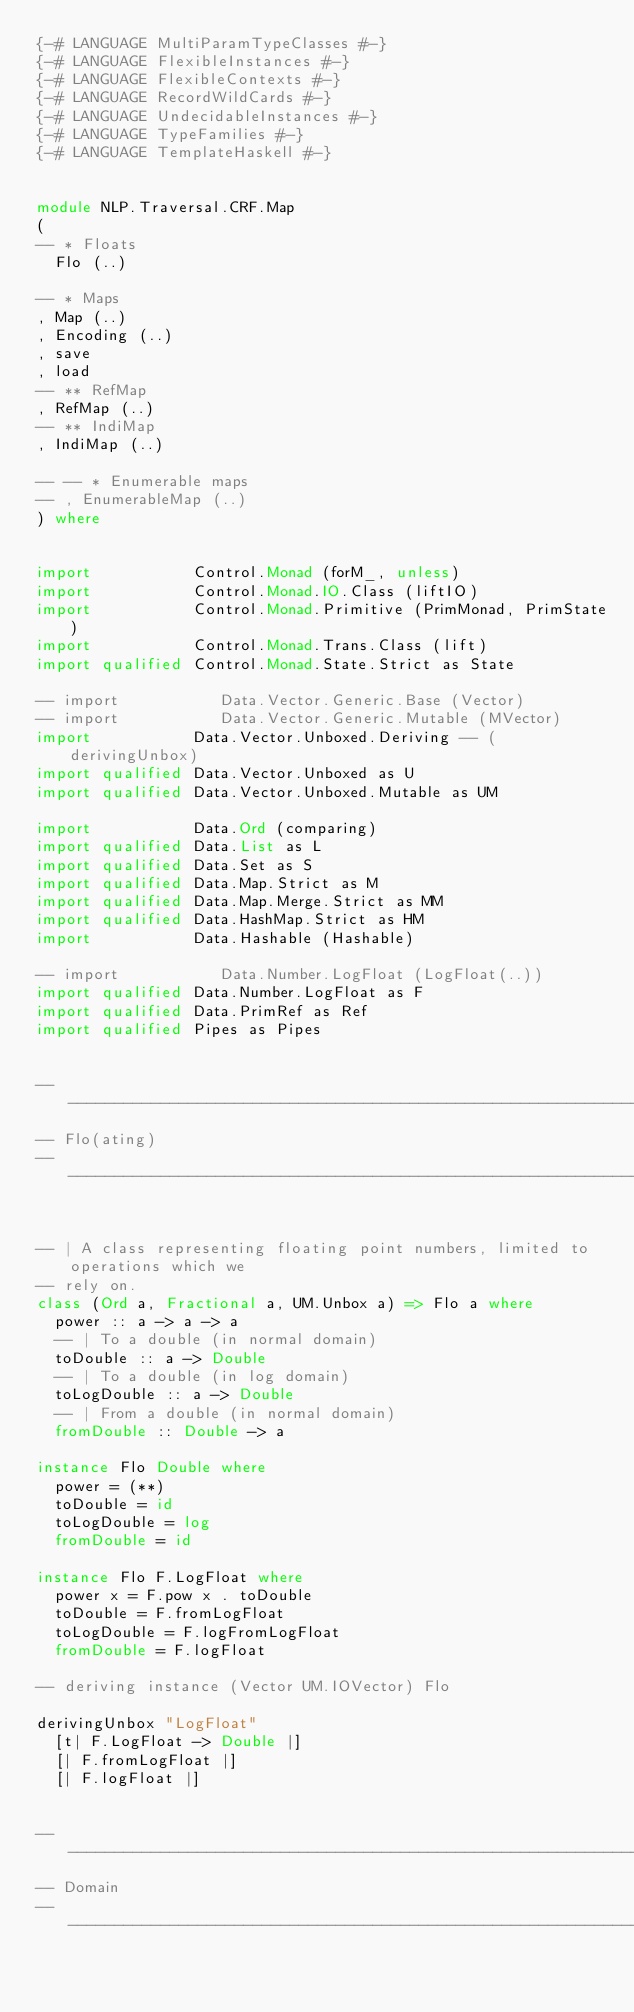<code> <loc_0><loc_0><loc_500><loc_500><_Haskell_>{-# LANGUAGE MultiParamTypeClasses #-}
{-# LANGUAGE FlexibleInstances #-}
{-# LANGUAGE FlexibleContexts #-}
{-# LANGUAGE RecordWildCards #-}
{-# LANGUAGE UndecidableInstances #-}
{-# LANGUAGE TypeFamilies #-}
{-# LANGUAGE TemplateHaskell #-}


module NLP.Traversal.CRF.Map
(
-- * Floats
  Flo (..)

-- * Maps
, Map (..)
, Encoding (..)
, save
, load
-- ** RefMap
, RefMap (..)
-- ** IndiMap
, IndiMap (..)

-- -- * Enumerable maps
-- , EnumerableMap (..)
) where


import           Control.Monad (forM_, unless)
import           Control.Monad.IO.Class (liftIO)
import           Control.Monad.Primitive (PrimMonad, PrimState)
import           Control.Monad.Trans.Class (lift)
import qualified Control.Monad.State.Strict as State

-- import           Data.Vector.Generic.Base (Vector)
-- import           Data.Vector.Generic.Mutable (MVector)
import           Data.Vector.Unboxed.Deriving -- (derivingUnbox)
import qualified Data.Vector.Unboxed as U
import qualified Data.Vector.Unboxed.Mutable as UM

import           Data.Ord (comparing)
import qualified Data.List as L
import qualified Data.Set as S
import qualified Data.Map.Strict as M
import qualified Data.Map.Merge.Strict as MM
import qualified Data.HashMap.Strict as HM
import           Data.Hashable (Hashable)

-- import           Data.Number.LogFloat (LogFloat(..))
import qualified Data.Number.LogFloat as F
import qualified Data.PrimRef as Ref
import qualified Pipes as Pipes


------------------------------------------------------------------
-- Flo(ating)
------------------------------------------------------------------


-- | A class representing floating point numbers, limited to operations which we
-- rely on.
class (Ord a, Fractional a, UM.Unbox a) => Flo a where
  power :: a -> a -> a
  -- | To a double (in normal domain)
  toDouble :: a -> Double
  -- | To a double (in log domain)
  toLogDouble :: a -> Double
  -- | From a double (in normal domain)
  fromDouble :: Double -> a

instance Flo Double where
  power = (**)
  toDouble = id
  toLogDouble = log
  fromDouble = id

instance Flo F.LogFloat where
  power x = F.pow x . toDouble
  toDouble = F.fromLogFloat
  toLogDouble = F.logFromLogFloat
  fromDouble = F.logFloat

-- deriving instance (Vector UM.IOVector) Flo

derivingUnbox "LogFloat"
  [t| F.LogFloat -> Double |]
  [| F.fromLogFloat |]
  [| F.logFloat |]


------------------------------------------------------------------
-- Domain
------------------------------------------------------------------

</code> 